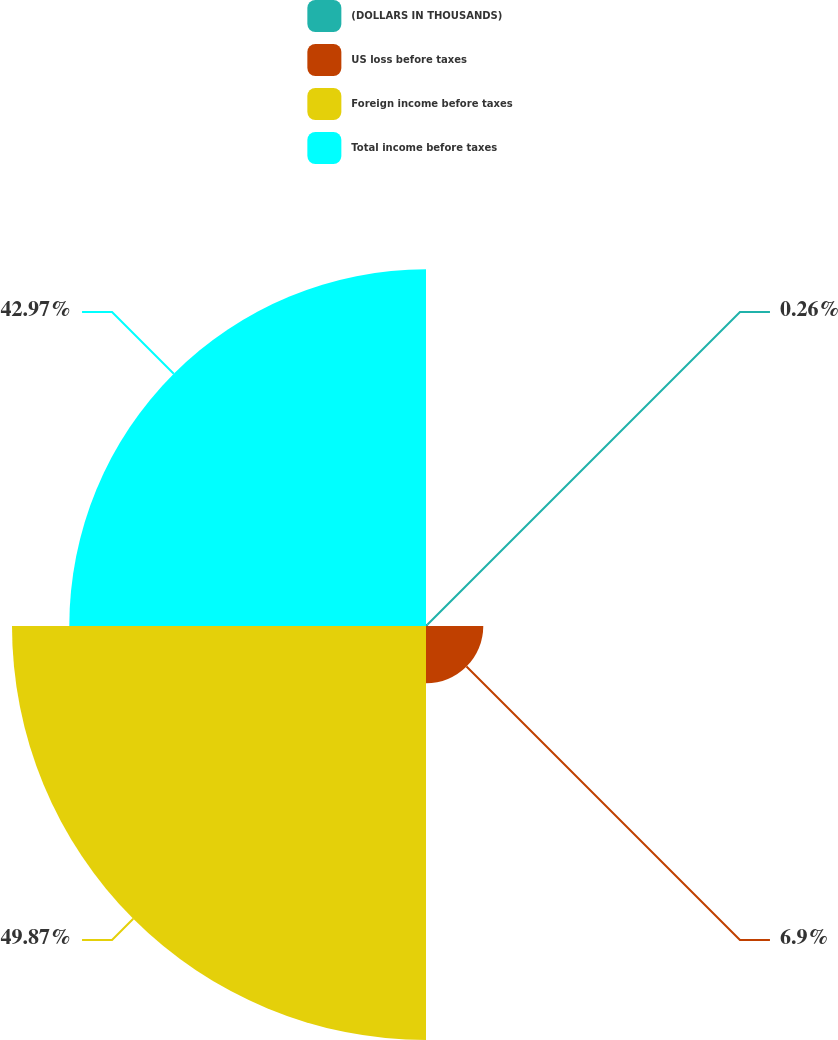Convert chart to OTSL. <chart><loc_0><loc_0><loc_500><loc_500><pie_chart><fcel>(DOLLARS IN THOUSANDS)<fcel>US loss before taxes<fcel>Foreign income before taxes<fcel>Total income before taxes<nl><fcel>0.26%<fcel>6.9%<fcel>49.87%<fcel>42.97%<nl></chart> 